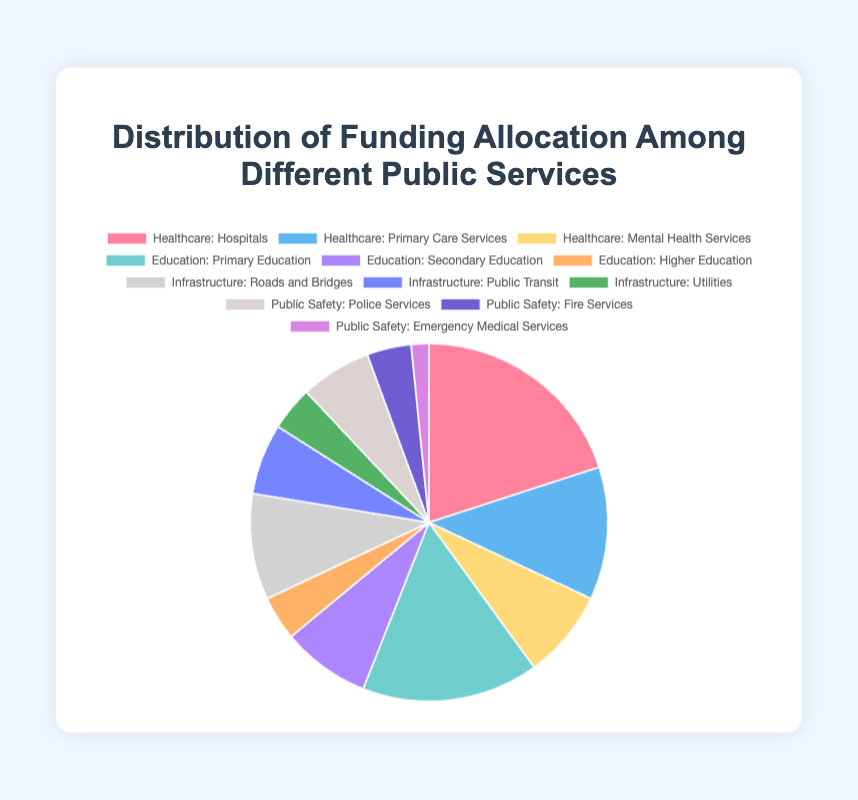What is the largest individual subcategory in the Healthcare category? Observe the Healthcare category and identify the subcategory with the highest value. Hospitals have the highest value at 25%.
Answer: Hospitals Which category has the smallest allocation, and what is its percentage? Compare the total allocation percentages of Healthcare, Education, Infrastructure, and Public Safety. Public Safety has the smallest allocation summing up to 15%.
Answer: Public Safety, 15% Which subcategory represents the smallest allocation overall? Look at all subcategories across different categories to find the smallest value. Emergency Medical Services in Public Safety is the smallest with 2%.
Answer: Emergency Medical Services What is the combined allocation for all subcategories within Education? Sum the percentages of Primary Education, Secondary Education, and Higher Education from the Education category. 20% + 10% + 5% equals 35%.
Answer: 35% What is the difference in allocation between Hospitals and Roads and Bridges? Subtract the percentage of Roads and Bridges from Hospitals. 25% (Hospitals) - 12% (Roads and Bridges) = 13%.
Answer: 13% How does the allocation for Police Services compare to Primary Care Services? Compare the percentages of Police Services and Primary Care Services. Police Services allocation is 8%, while Primary Care Services is 15%.
Answer: Primary Care Services is 7% higher than Police Services Which subcategories within Infrastructure have equal allocation percentages, and what are they? Identify subcategories in Infrastructure with the same percentage value. Public Transit and Utilities both have an 8% allocation.
Answer: Public Transit and Utilities, 8% If you combine the allocations of all Mental Health Services and Emergency Medical Services, what is the total percentage? Add the percentage values of Mental Health Services and Emergency Medical Services. 10% (Mental Health Services) + 2% (Emergency Medical Services) = 12%.
Answer: 12% Does Education as a whole receive more funding than Healthcare? Sum the allocation percentages of all subcategories in Education and Healthcare, then compare. Education has 35%, and Healthcare has 50%. Healthcare receives more funding.
Answer: No, Healthcare receives more 